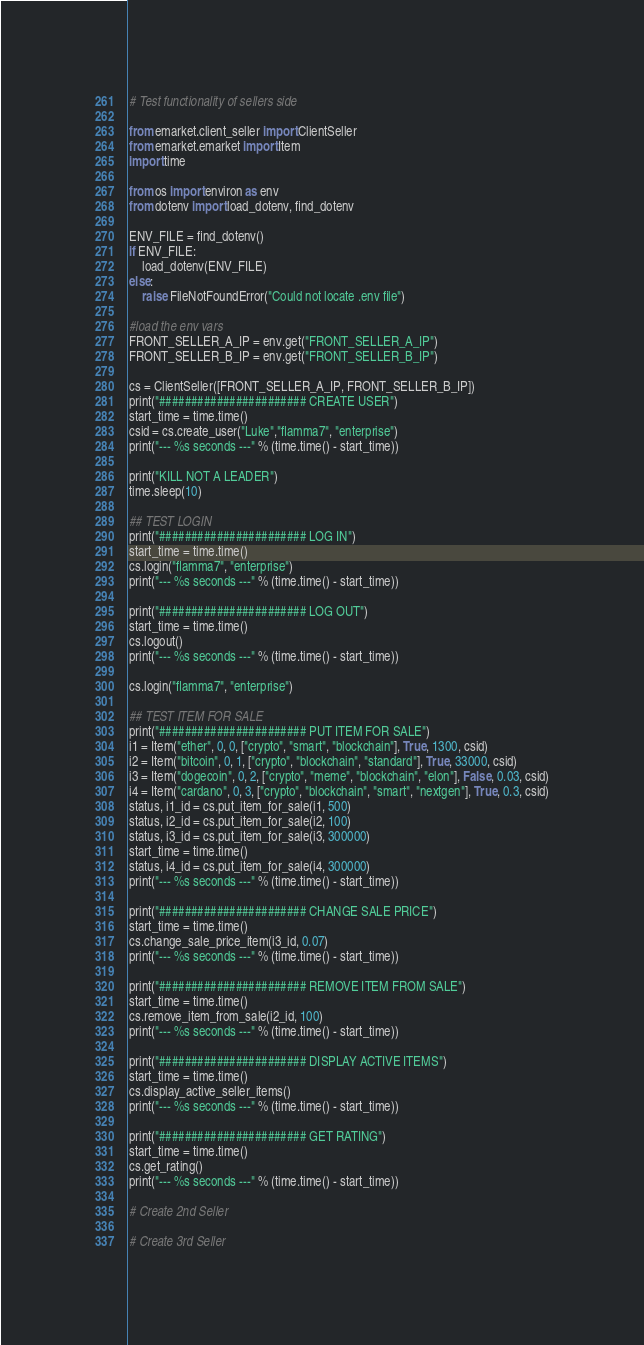Convert code to text. <code><loc_0><loc_0><loc_500><loc_500><_Python_># Test functionality of sellers side

from emarket.client_seller import ClientSeller
from emarket.emarket import Item
import time

from os import environ as env
from dotenv import load_dotenv, find_dotenv

ENV_FILE = find_dotenv()
if ENV_FILE:
    load_dotenv(ENV_FILE)
else:
    raise FileNotFoundError("Could not locate .env file")

#load the env vars
FRONT_SELLER_A_IP = env.get("FRONT_SELLER_A_IP")
FRONT_SELLER_B_IP = env.get("FRONT_SELLER_B_IP")

cs = ClientSeller([FRONT_SELLER_A_IP, FRONT_SELLER_B_IP])
print("####################### CREATE USER")
start_time = time.time()
csid = cs.create_user("Luke","flamma7", "enterprise")
print("--- %s seconds ---" % (time.time() - start_time))

print("KILL NOT A LEADER")
time.sleep(10)

## TEST LOGIN
print("####################### LOG IN")
start_time = time.time()
cs.login("flamma7", "enterprise")
print("--- %s seconds ---" % (time.time() - start_time))

print("####################### LOG OUT")
start_time = time.time()
cs.logout()
print("--- %s seconds ---" % (time.time() - start_time))

cs.login("flamma7", "enterprise")

## TEST ITEM FOR SALE
print("####################### PUT ITEM FOR SALE")
i1 = Item("ether", 0, 0, ["crypto", "smart", "blockchain"], True, 1300, csid)
i2 = Item("bitcoin", 0, 1, ["crypto", "blockchain", "standard"], True, 33000, csid)
i3 = Item("dogecoin", 0, 2, ["crypto", "meme", "blockchain", "elon"], False, 0.03, csid)
i4 = Item("cardano", 0, 3, ["crypto", "blockchain", "smart", "nextgen"], True, 0.3, csid)
status, i1_id = cs.put_item_for_sale(i1, 500)
status, i2_id = cs.put_item_for_sale(i2, 100)
status, i3_id = cs.put_item_for_sale(i3, 300000)
start_time = time.time()
status, i4_id = cs.put_item_for_sale(i4, 300000)
print("--- %s seconds ---" % (time.time() - start_time))

print("####################### CHANGE SALE PRICE")
start_time = time.time()
cs.change_sale_price_item(i3_id, 0.07)
print("--- %s seconds ---" % (time.time() - start_time))

print("####################### REMOVE ITEM FROM SALE")
start_time = time.time()
cs.remove_item_from_sale(i2_id, 100)
print("--- %s seconds ---" % (time.time() - start_time))

print("####################### DISPLAY ACTIVE ITEMS")
start_time = time.time()
cs.display_active_seller_items()
print("--- %s seconds ---" % (time.time() - start_time))

print("####################### GET RATING")
start_time = time.time()
cs.get_rating()
print("--- %s seconds ---" % (time.time() - start_time))

# Create 2nd Seller

# Create 3rd Seller</code> 